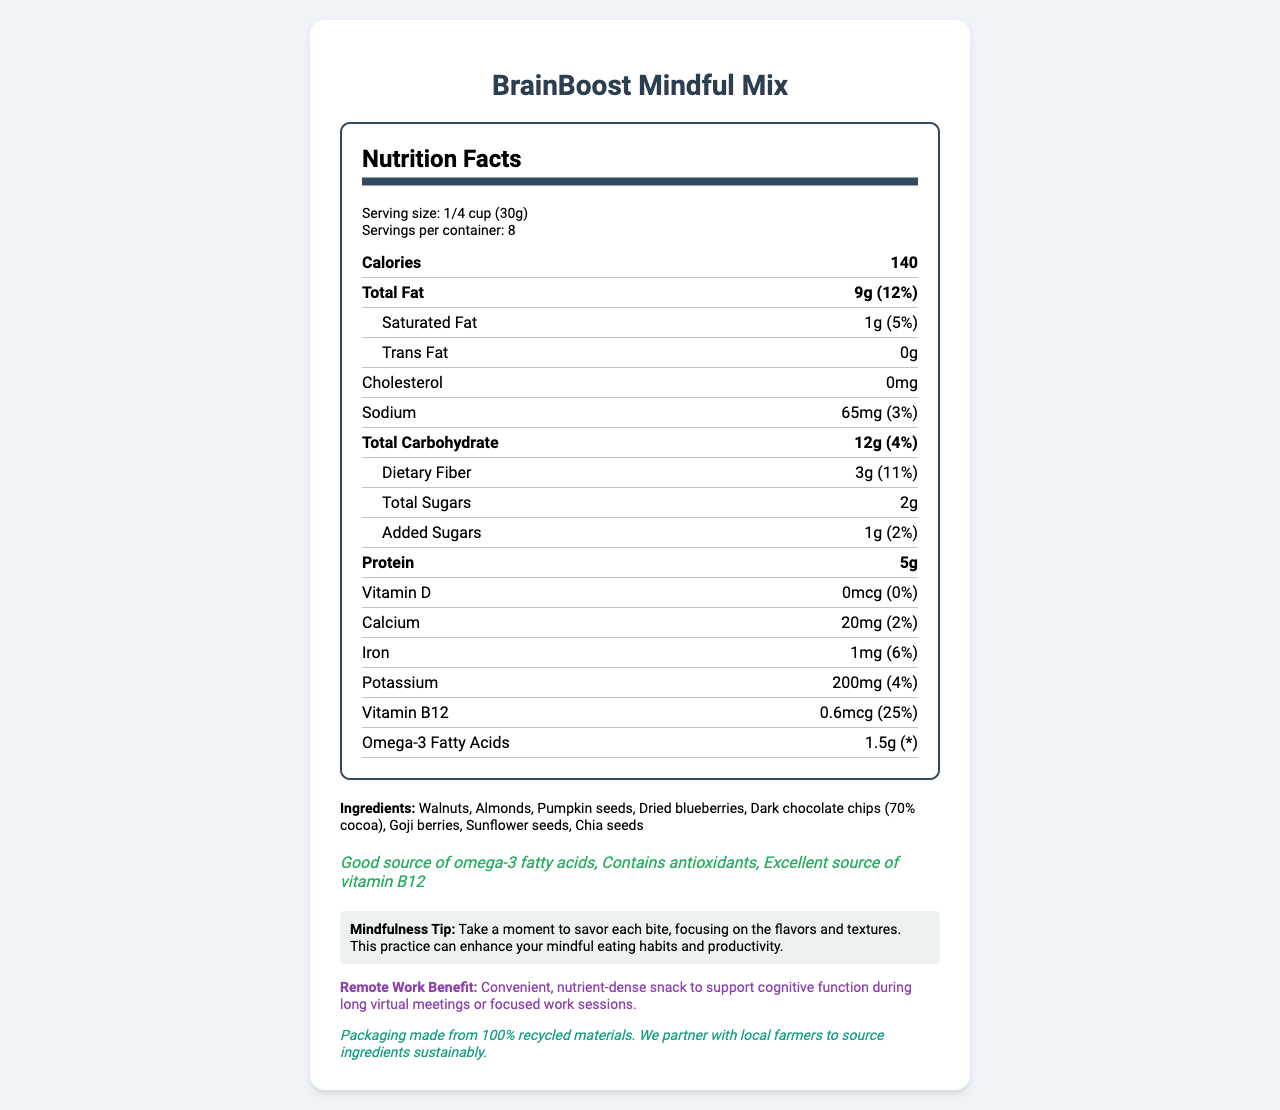what is the serving size of BrainBoost Mindful Mix? The serving size is explicitly mentioned in the serving info section at the beginning of the nutrition facts.
Answer: 1/4 cup (30g) how many servings are there per container? The document states that there are 8 servings per container, located in the serving info section.
Answer: 8 how many calories are in one serving? The number of calories per serving is shown in bold at the top of the nutrition facts section.
Answer: 140 how much protein is in one serving? The amount of protein is listed under the nutrition item "Protein" in the nutrition facts section.
Answer: 5g what type of fats and how much of them are present? These amounts are listed under the "Total Fat" and "Omega-3 Fatty Acids" sections in the nutrition facts.
Answer: Total Fat: 9g, Saturated Fat: 1g, Trans Fat: 0g, Omega-3 Fatty Acids: 1.5g which of the following nutrients has the highest daily value percentage? A. Calcium B. Iron C. Sodium D. Vitamin B12 Vitamin B12 has a daily value of 25%, which is higher than Calcium (2%), Iron (6%), and Sodium (3%).
Answer: D. Vitamin B12 what is the first ingredient listed for BrainBoost Mindful Mix? A. Almonds B. Walnuts C. Dried Blueberries D. Chia Seeds The first ingredient listed in the ingredients section is Walnuts.
Answer: B. Walnuts are there any tree nuts in BrainBoost Mindful Mix? The allergen information states that the product contains tree nuts.
Answer: Yes is this product a good source of antioxidants? One of the health claims explicitly states that it contains antioxidants.
Answer: Yes summarize the main idea of the document. The document aims to inform consumers about the nutritional value and benefits of BrainBoost Mindful Mix, promoting its use for cognitive function and sustainable practices.
Answer: The document provides detailed nutrition facts, ingredient list, allergen information, and health claims for BrainBoost Mindful Mix. It emphasizes the product's benefits for brain function, productivity, and sustainability, includes mindfulness and remote work tips, and highlights its eco-friendly packaging. what is the exact amount of added sugars in this product? The amount of added sugars is listed as 1g in the nutrition facts section under "Added Sugars".
Answer: 1g how much dietary fiber does one serving contain and what is its daily value percentage? The dietary fiber content is 3g, and the daily value percentage is 11%, as shown in the nutrition facts.
Answer: 3g, 11% is the BrainBoost Mindful Mix free from cholesterol? The nutrition facts state that the product contains 0mg of cholesterol.
Answer: Yes what is the purpose of the mindfulness tip on the label? The mindfulness tip suggests savoring each bite and focusing on flavors and textures to promote mindful eating and productivity.
Answer: To encourage mindful eating habits and enhance productivity. does the packaging contain any recycled materials? The sustainability note mentions that the packaging is made from 100% recycled materials.
Answer: Yes how much vitamin D is in one serving? The nutrition facts list the vitamin D content as 0mcg.
Answer: 0mcg what is the role of the remote work benefit section? The remote work benefit highlights how the snack mix is suitable for remote workers looking to maintain focus and productivity.
Answer: To emphasize the product's convenience and nutrient density to support cognitive function during long virtual meetings or focused work sessions. which ingredient provides the omega-3 fatty acids in this mix? The document lists the amount of omega-3 fatty acids but does not specify which ingredient provides them.
Answer: Cannot be determined 